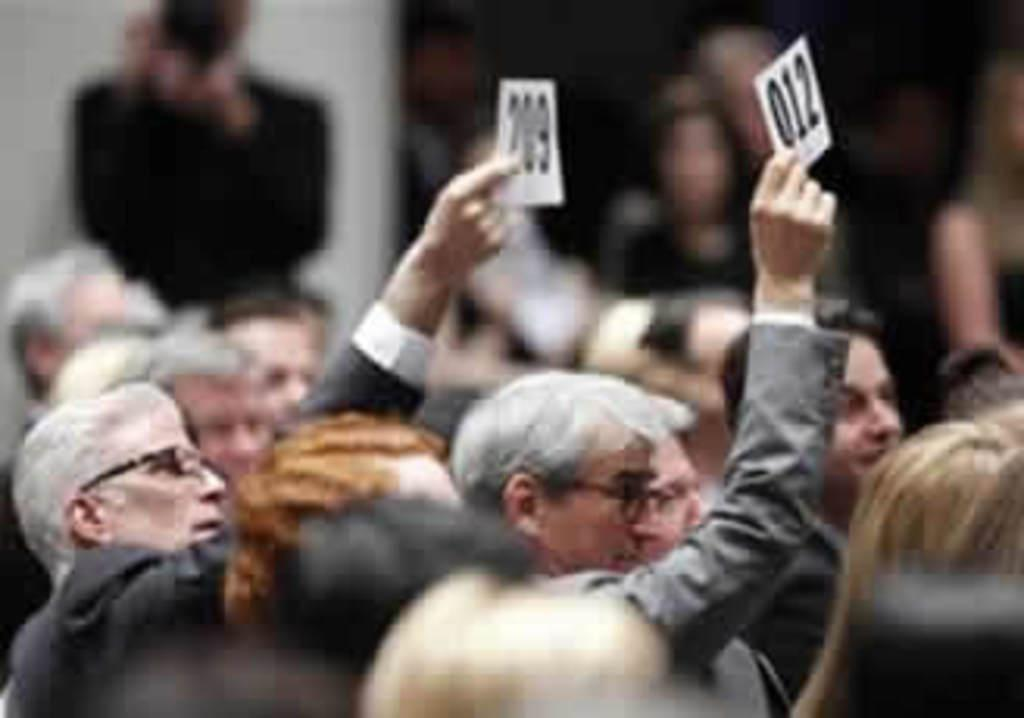How many people are in the image? There is a group of people standing in the image. What are two persons in the group doing? Two persons in the group are holding a paper. What can be seen in the background of the image? There is a wall in the background of the image. What is the color of the wall? The wall is white in color. How many chairs are visible in the image? There are no chairs visible in the image. What type of wave is being depicted in the image? There is no wave present in the image. 